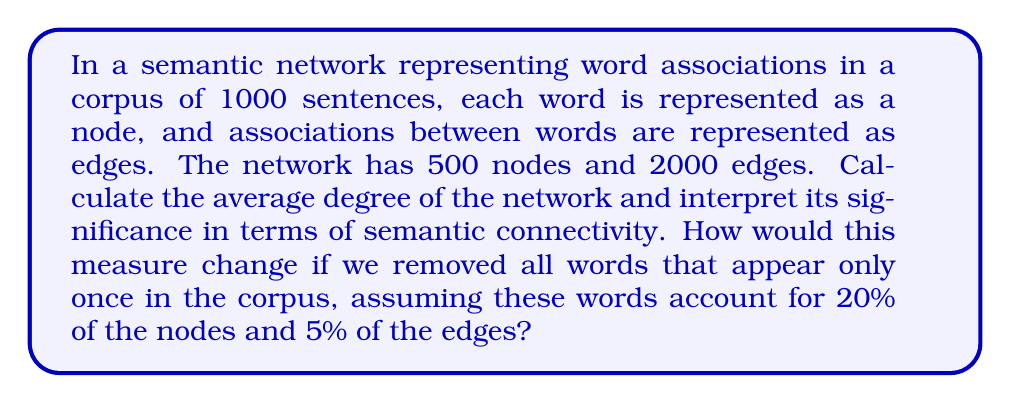Provide a solution to this math problem. To solve this problem, we'll follow these steps:

1. Calculate the initial average degree:
   The average degree of a network is given by the formula:
   
   $$\bar{k} = \frac{2E}{N}$$
   
   where $E$ is the number of edges and $N$ is the number of nodes.

   Initial average degree:
   $$\bar{k}_1 = \frac{2 \cdot 2000}{500} = 8$$

2. Interpret the significance:
   An average degree of 8 indicates that each word in the network is, on average, directly associated with 8 other words. This suggests a relatively high level of semantic connectivity in the corpus.

3. Calculate the new number of nodes and edges after removal:
   Nodes removed: $500 \cdot 20\% = 100$
   New number of nodes: $500 - 100 = 400$
   
   Edges removed: $2000 \cdot 5\% = 100$
   New number of edges: $2000 - 100 = 1900$

4. Calculate the new average degree:
   $$\bar{k}_2 = \frac{2 \cdot 1900}{400} = 9.5$$

5. Compare the change:
   The average degree increased from 8 to 9.5, indicating that removing words that appear only once (likely rare or specialized terms) increases the overall connectivity of the semantic network.
Answer: Initial average degree: 8
New average degree after removal: 9.5
The average degree increases by 1.5, indicating that removing infrequent words enhances the overall semantic connectivity of the network. 